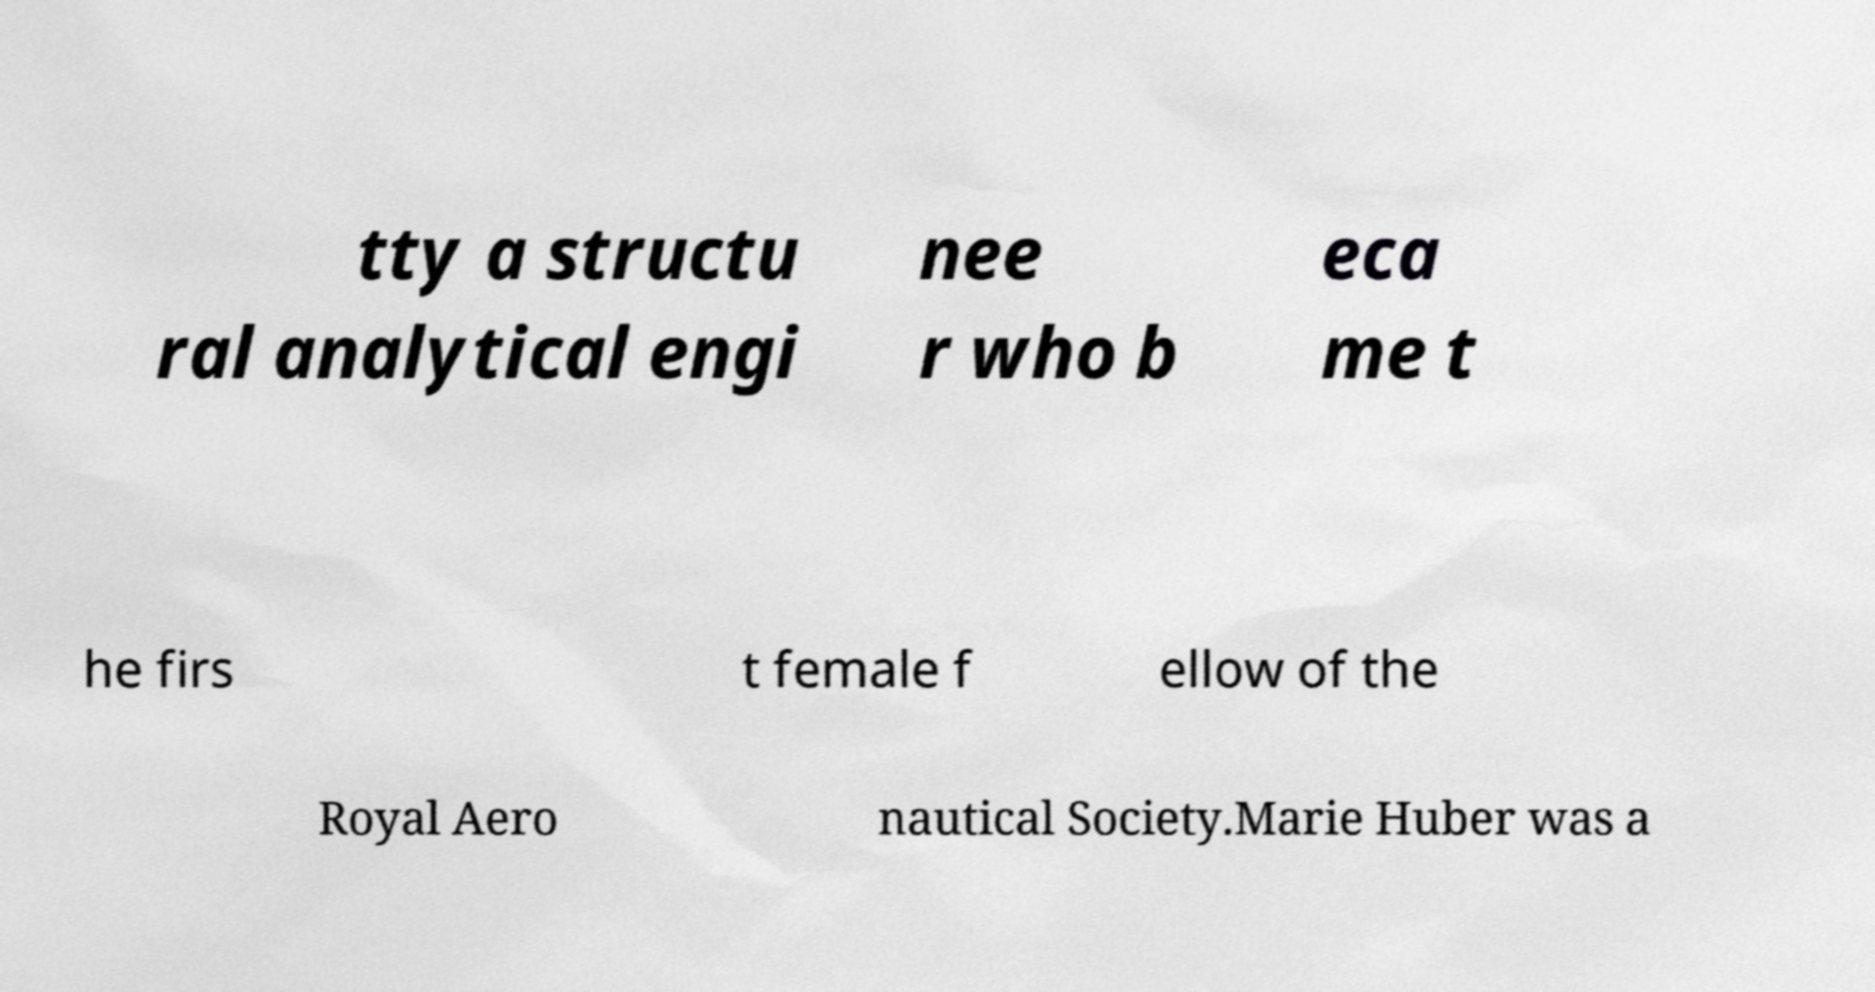Please read and relay the text visible in this image. What does it say? tty a structu ral analytical engi nee r who b eca me t he firs t female f ellow of the Royal Aero nautical Society.Marie Huber was a 